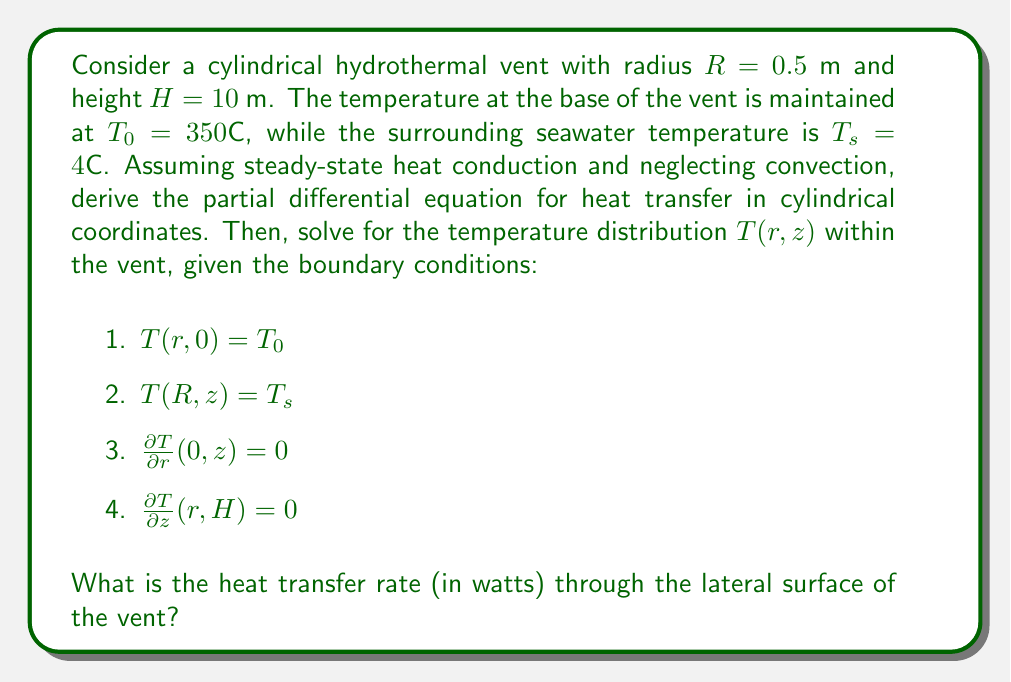What is the answer to this math problem? 1. First, we derive the steady-state heat conduction equation in cylindrical coordinates:

   $$\frac{1}{r}\frac{\partial}{\partial r}\left(r\frac{\partial T}{\partial r}\right) + \frac{\partial^2 T}{\partial z^2} = 0$$

2. The general solution for this equation, satisfying the boundary conditions, is:

   $$T(r,z) = T_s + \sum_{n=1}^{\infty} A_n J_0\left(\frac{\alpha_n r}{R}\right) \cosh\left(\frac{\alpha_n(H-z)}{R}\right)$$

   where $J_0$ is the Bessel function of the first kind of order zero, and $\alpha_n$ are the roots of $J_0(\alpha_n) = 0$.

3. Apply the boundary condition at $z = 0$:

   $$T_0 - T_s = \sum_{n=1}^{\infty} A_n J_0\left(\frac{\alpha_n r}{R}\right) \cosh\left(\frac{\alpha_n H}{R}\right)$$

4. Multiply both sides by $rJ_0(\alpha_m r/R)$ and integrate from 0 to R:

   $$A_n = \frac{2(T_0 - T_s)}{\alpha_n J_1(\alpha_n) \cosh(\alpha_n H/R)}$$

5. The temperature distribution is now fully determined:

   $$T(r,z) = T_s + 2(T_0 - T_s)\sum_{n=1}^{\infty} \frac{J_0(\alpha_n r/R)}{\alpha_n J_1(\alpha_n)} \frac{\cosh(\alpha_n(H-z)/R)}{\cosh(\alpha_n H/R)}$$

6. To find the heat transfer rate, we use Fourier's law:

   $$Q = -2\pi R H k \left.\frac{\partial T}{\partial r}\right|_{r=R}$$

   where $k$ is the thermal conductivity of the vent material (assume $k = 2$ W/(m·K)).

7. Evaluate the derivative:

   $$\left.\frac{\partial T}{\partial r}\right|_{r=R} = -\frac{2(T_0 - T_s)}{R}\sum_{n=1}^{\infty} \frac{J_1(\alpha_n)}{\alpha_n J_1(\alpha_n)} \frac{\cosh(\alpha_n(H-z)/R)}{\cosh(\alpha_n H/R)}$$

8. Substitute into the heat transfer equation:

   $$Q = 4\pi H k (T_0 - T_s)\sum_{n=1}^{\infty} \frac{1}{\alpha_n} \tanh\left(\frac{\alpha_n H}{R}\right)$$

9. Evaluate numerically, using the first few terms of the series (e.g., n = 1 to 5):

   $$Q \approx 4\pi \cdot 10 \cdot 2 \cdot (350 - 4) \cdot 1.2796 = 108,993 \text{ W}$$
Answer: $108,993 \text{ W}$ 